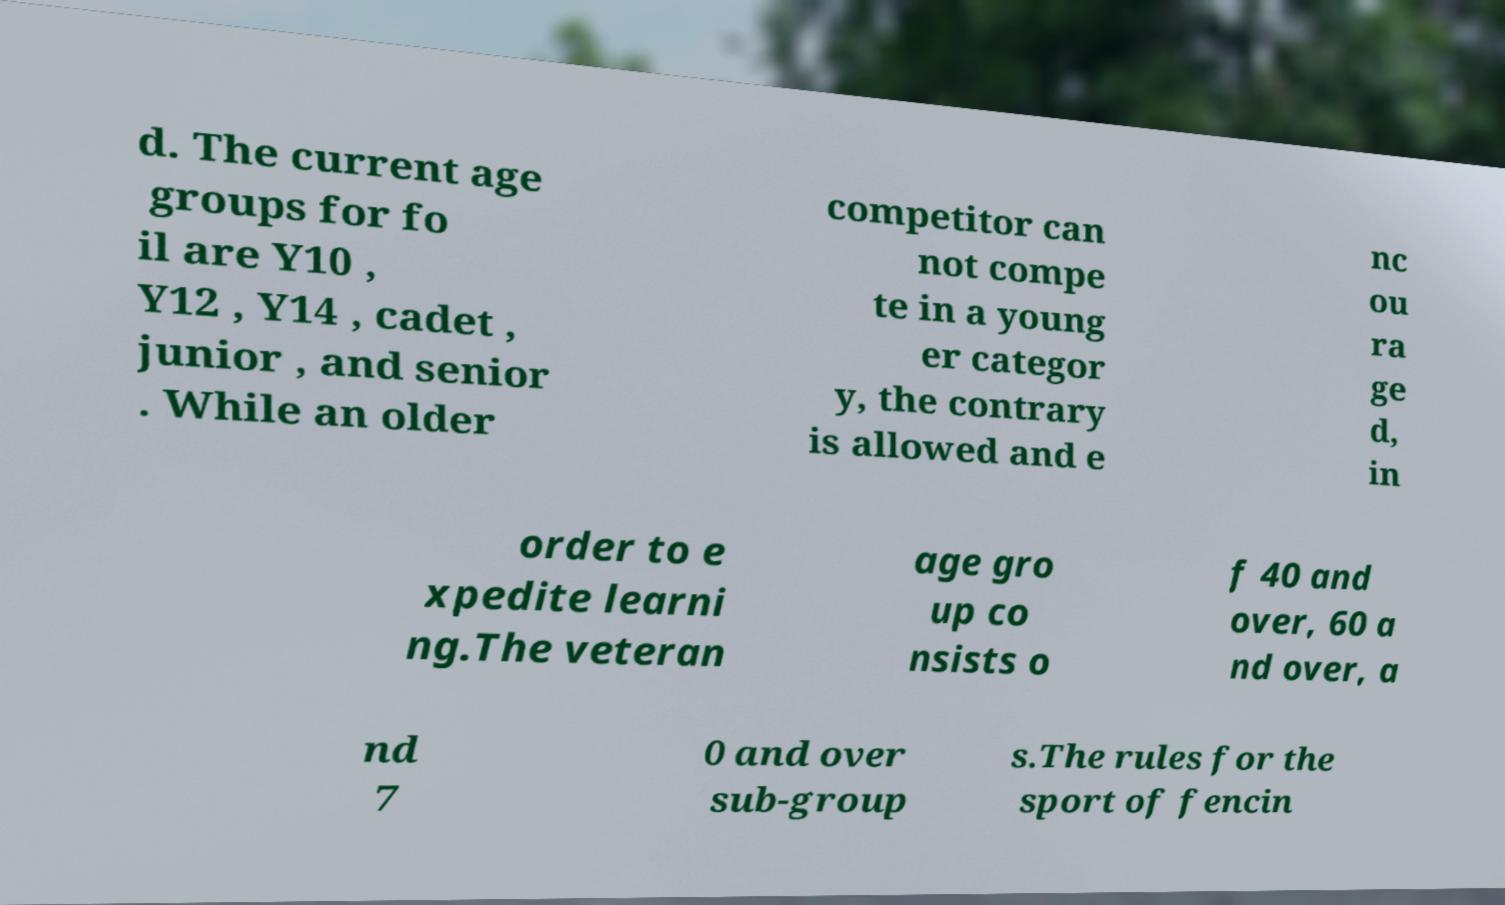Could you assist in decoding the text presented in this image and type it out clearly? d. The current age groups for fo il are Y10 , Y12 , Y14 , cadet , junior , and senior . While an older competitor can not compe te in a young er categor y, the contrary is allowed and e nc ou ra ge d, in order to e xpedite learni ng.The veteran age gro up co nsists o f 40 and over, 60 a nd over, a nd 7 0 and over sub-group s.The rules for the sport of fencin 